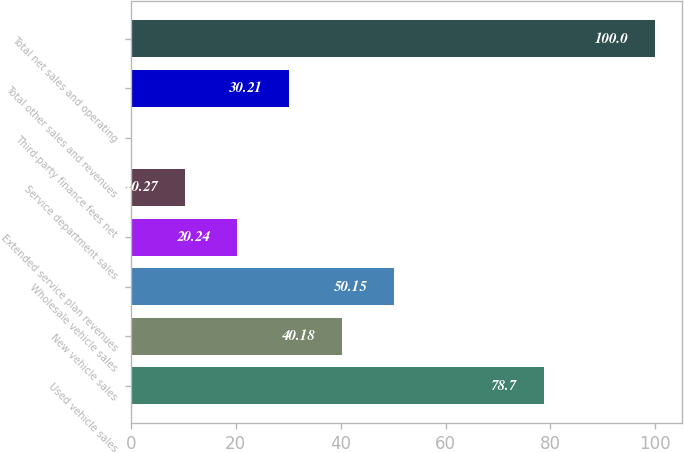<chart> <loc_0><loc_0><loc_500><loc_500><bar_chart><fcel>Used vehicle sales<fcel>New vehicle sales<fcel>Wholesale vehicle sales<fcel>Extended service plan revenues<fcel>Service department sales<fcel>Third-party finance fees net<fcel>Total other sales and revenues<fcel>Total net sales and operating<nl><fcel>78.7<fcel>40.18<fcel>50.15<fcel>20.24<fcel>10.27<fcel>0.3<fcel>30.21<fcel>100<nl></chart> 